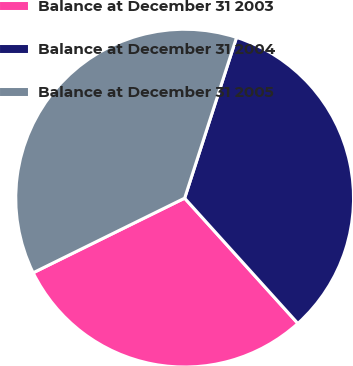Convert chart to OTSL. <chart><loc_0><loc_0><loc_500><loc_500><pie_chart><fcel>Balance at December 31 2003<fcel>Balance at December 31 2004<fcel>Balance at December 31 2005<nl><fcel>29.41%<fcel>33.33%<fcel>37.25%<nl></chart> 